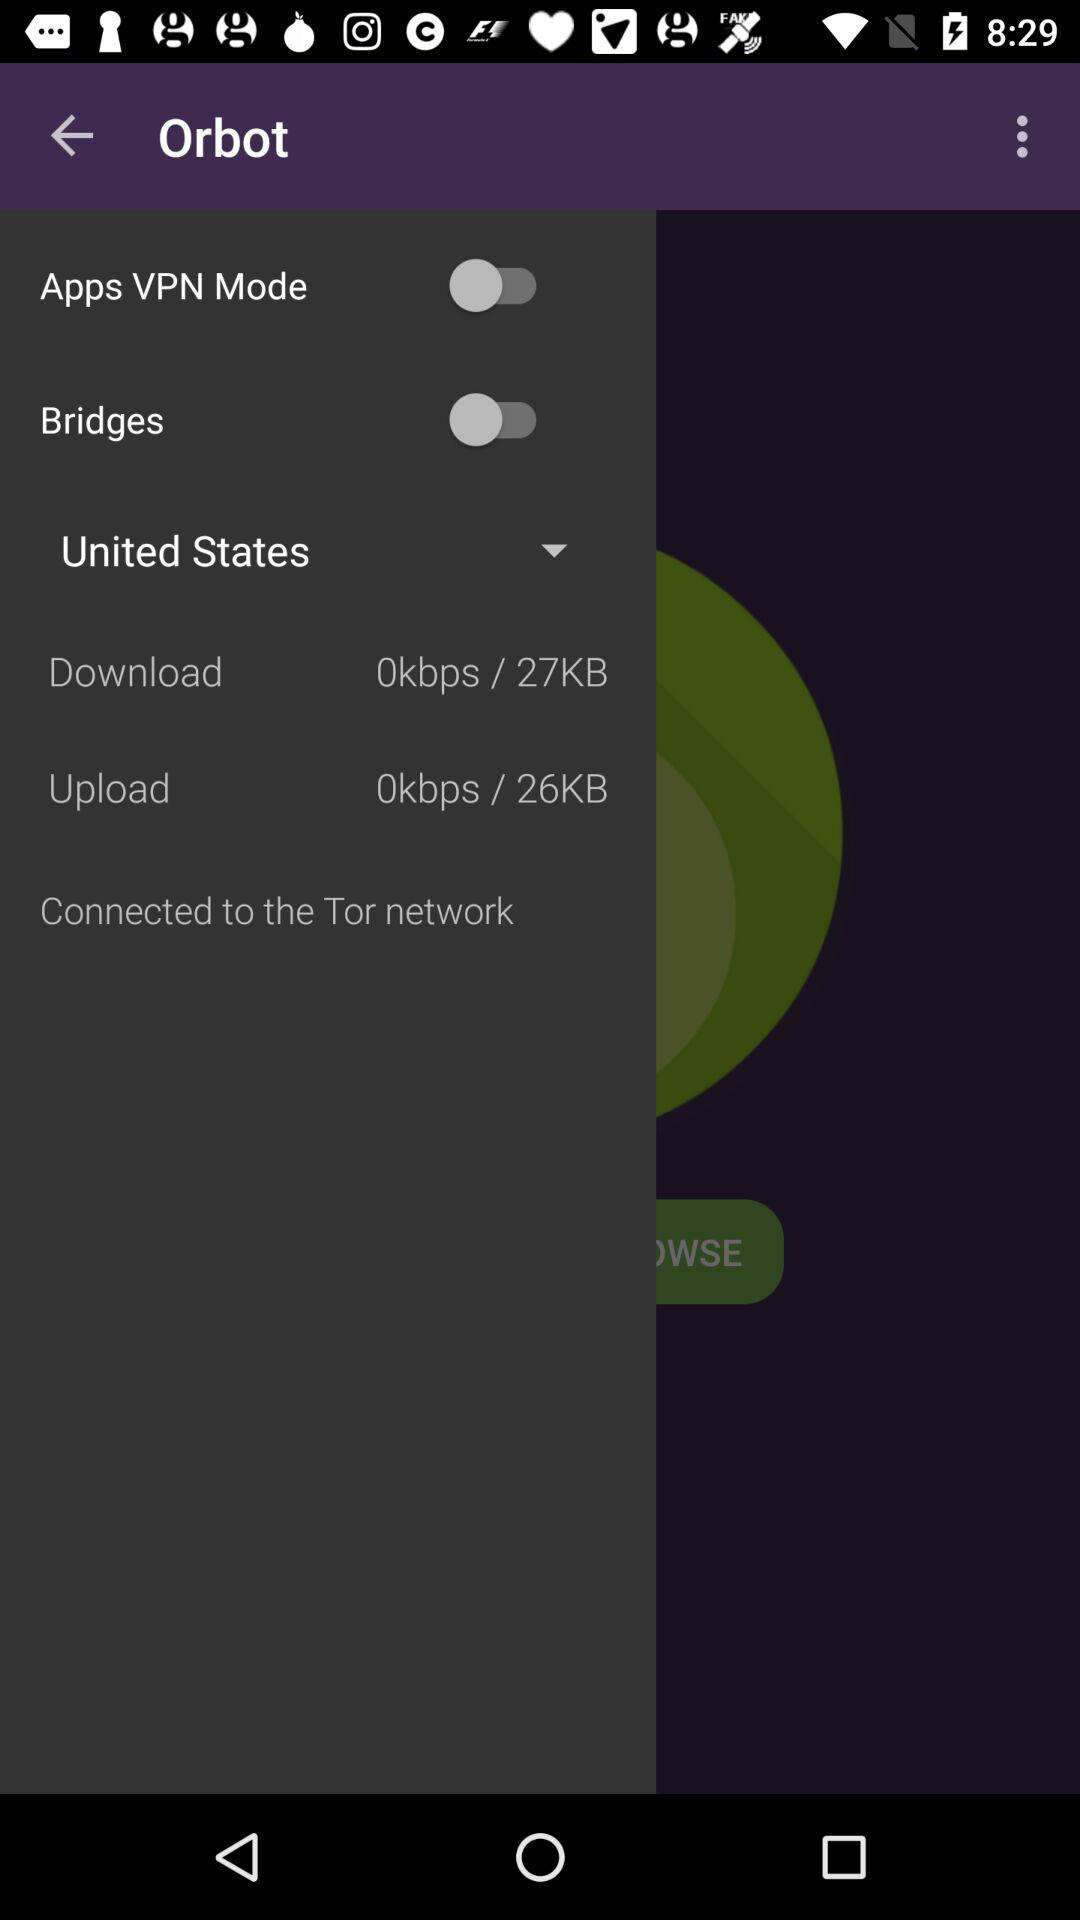Which country is selected? The selected country is the United States. 